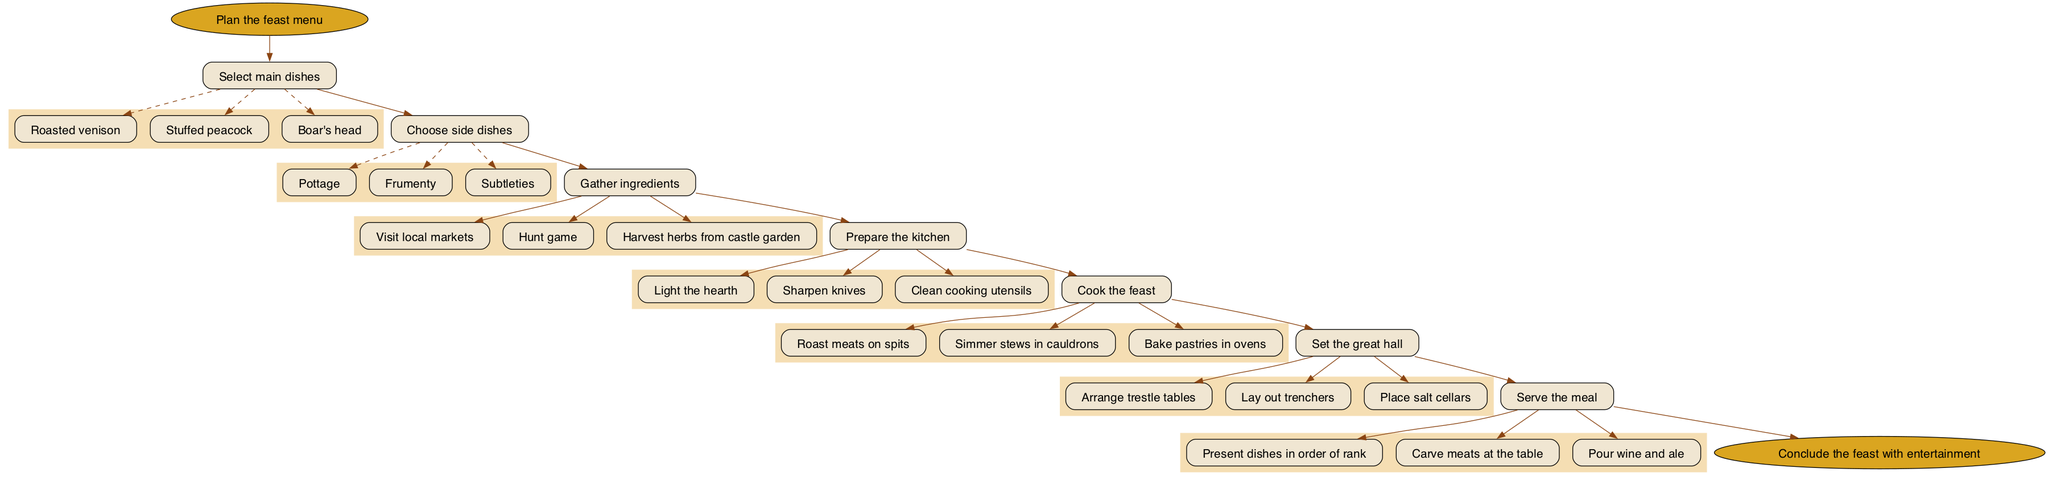What is the first step in preparing the feast? The diagram starts with the node "Plan the feast menu," which indicates that this is the initial step of the process.
Answer: Plan the feast menu How many main dishes can be selected? The "Select main dishes" step lists three options: Roasted venison, Stuffed peacock, and Boar's head. Therefore, the number of options is three.
Answer: 3 Which step follows "Gather ingredients"? The diagram shows a flow where "Gather ingredients" is followed by the step "Prepare the kitchen," indicating the sequence in the preparation process.
Answer: Prepare the kitchen What is the last step in the preparation process? The final node in the diagram is "Conclude the feast with entertainment," which represents the concluding part of the feast preparation process.
Answer: Conclude the feast with entertainment List one of the substeps involved in cooking the feast. In the "Cook the feast" step, one of the substeps is "Roast meats on spits," which illustrates part of the cooking process for the feast.
Answer: Roast meats on spits What is required to set the great hall? The diagram specifies several substeps for setting the great hall, one of which is "Arrange trestle tables." This is essential for preparing the dining area.
Answer: Arrange trestle tables Which step involves presenting dishes? The step named "Serve the meal" includes the substep "Present dishes in order of rank," indicating the specific task related to the serving of food.
Answer: Serve the meal How does the feast preparation process conclude? The process concludes with the step "Conclude the feast with entertainment," indicating that entertainment follows the meal serving, marking the end of the preparation process.
Answer: Conclude the feast with entertainment Explain the relationship between "Prepare the kitchen" and "Cook the feast." The diagram flow indicates that after "Prepare the kitchen" is completed, the next step is "Cook the feast," showing a direct sequence from preparing the kitchen to cooking.
Answer: Cook the feast 